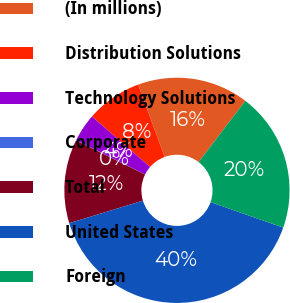<chart> <loc_0><loc_0><loc_500><loc_500><pie_chart><fcel>(In millions)<fcel>Distribution Solutions<fcel>Technology Solutions<fcel>Corporate<fcel>Total<fcel>United States<fcel>Foreign<nl><fcel>15.99%<fcel>8.02%<fcel>4.03%<fcel>0.04%<fcel>12.01%<fcel>39.92%<fcel>19.98%<nl></chart> 